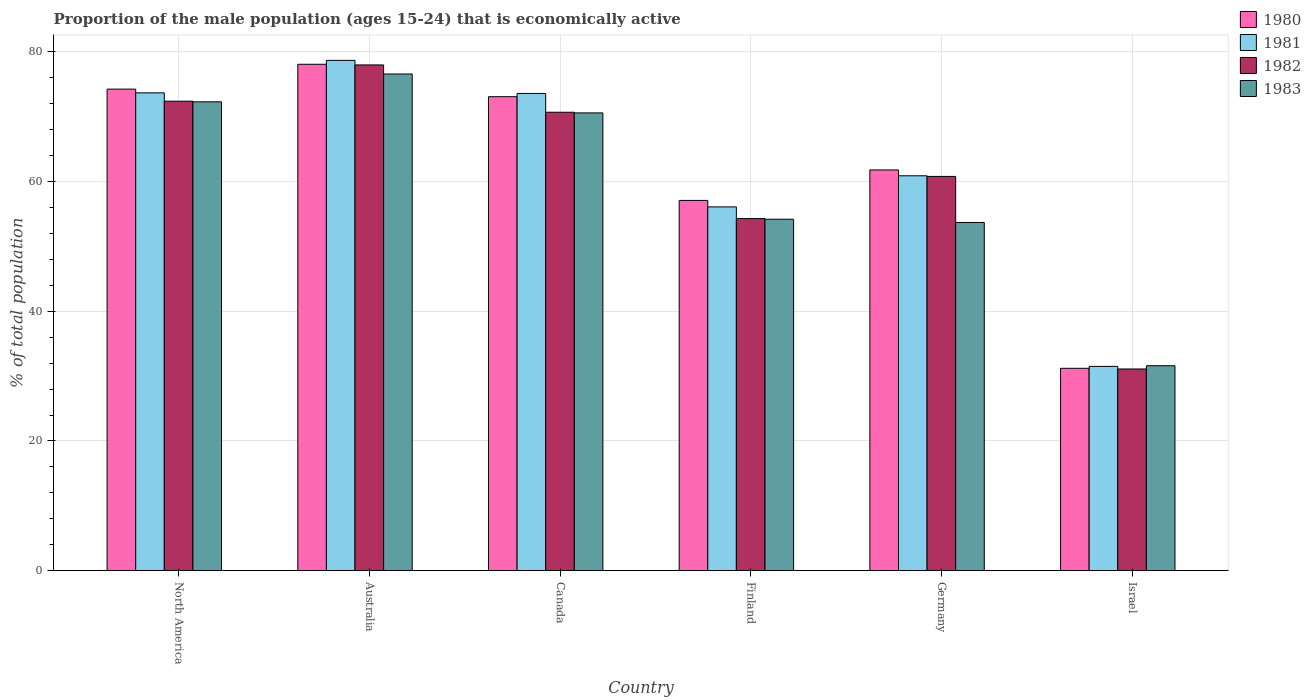How many different coloured bars are there?
Your answer should be very brief. 4. Are the number of bars per tick equal to the number of legend labels?
Your answer should be very brief. Yes. Are the number of bars on each tick of the X-axis equal?
Provide a succinct answer. Yes. What is the label of the 5th group of bars from the left?
Provide a succinct answer. Germany. In how many cases, is the number of bars for a given country not equal to the number of legend labels?
Give a very brief answer. 0. What is the proportion of the male population that is economically active in 1980 in Australia?
Offer a very short reply. 78.1. Across all countries, what is the maximum proportion of the male population that is economically active in 1980?
Offer a terse response. 78.1. Across all countries, what is the minimum proportion of the male population that is economically active in 1980?
Give a very brief answer. 31.2. What is the total proportion of the male population that is economically active in 1982 in the graph?
Provide a short and direct response. 367.31. What is the difference between the proportion of the male population that is economically active in 1981 in Canada and that in Germany?
Your response must be concise. 12.7. What is the difference between the proportion of the male population that is economically active in 1983 in Canada and the proportion of the male population that is economically active in 1980 in Germany?
Ensure brevity in your answer.  8.8. What is the average proportion of the male population that is economically active in 1981 per country?
Your answer should be very brief. 62.41. What is the difference between the proportion of the male population that is economically active of/in 1981 and proportion of the male population that is economically active of/in 1982 in Finland?
Your answer should be compact. 1.8. What is the ratio of the proportion of the male population that is economically active in 1980 in Canada to that in Israel?
Your answer should be compact. 2.34. Is the proportion of the male population that is economically active in 1980 in Canada less than that in Finland?
Keep it short and to the point. No. Is the difference between the proportion of the male population that is economically active in 1981 in Finland and Germany greater than the difference between the proportion of the male population that is economically active in 1982 in Finland and Germany?
Give a very brief answer. Yes. What is the difference between the highest and the second highest proportion of the male population that is economically active in 1982?
Your answer should be compact. 1.71. What is the difference between the highest and the lowest proportion of the male population that is economically active in 1982?
Offer a very short reply. 46.9. Is the sum of the proportion of the male population that is economically active in 1980 in Finland and Israel greater than the maximum proportion of the male population that is economically active in 1981 across all countries?
Give a very brief answer. Yes. Is it the case that in every country, the sum of the proportion of the male population that is economically active in 1983 and proportion of the male population that is economically active in 1982 is greater than the sum of proportion of the male population that is economically active in 1980 and proportion of the male population that is economically active in 1981?
Ensure brevity in your answer.  No. Is it the case that in every country, the sum of the proportion of the male population that is economically active in 1982 and proportion of the male population that is economically active in 1980 is greater than the proportion of the male population that is economically active in 1983?
Make the answer very short. Yes. Are all the bars in the graph horizontal?
Ensure brevity in your answer.  No. Where does the legend appear in the graph?
Give a very brief answer. Top right. How many legend labels are there?
Keep it short and to the point. 4. What is the title of the graph?
Provide a succinct answer. Proportion of the male population (ages 15-24) that is economically active. Does "1984" appear as one of the legend labels in the graph?
Provide a short and direct response. No. What is the label or title of the X-axis?
Provide a succinct answer. Country. What is the label or title of the Y-axis?
Offer a very short reply. % of total population. What is the % of total population in 1980 in North America?
Provide a succinct answer. 74.27. What is the % of total population of 1981 in North America?
Make the answer very short. 73.69. What is the % of total population in 1982 in North America?
Keep it short and to the point. 72.41. What is the % of total population of 1983 in North America?
Give a very brief answer. 72.31. What is the % of total population in 1980 in Australia?
Offer a terse response. 78.1. What is the % of total population in 1981 in Australia?
Keep it short and to the point. 78.7. What is the % of total population in 1982 in Australia?
Offer a terse response. 78. What is the % of total population in 1983 in Australia?
Ensure brevity in your answer.  76.6. What is the % of total population of 1980 in Canada?
Offer a very short reply. 73.1. What is the % of total population in 1981 in Canada?
Make the answer very short. 73.6. What is the % of total population in 1982 in Canada?
Provide a short and direct response. 70.7. What is the % of total population in 1983 in Canada?
Make the answer very short. 70.6. What is the % of total population in 1980 in Finland?
Provide a short and direct response. 57.1. What is the % of total population of 1981 in Finland?
Keep it short and to the point. 56.1. What is the % of total population in 1982 in Finland?
Your answer should be very brief. 54.3. What is the % of total population of 1983 in Finland?
Keep it short and to the point. 54.2. What is the % of total population of 1980 in Germany?
Provide a succinct answer. 61.8. What is the % of total population of 1981 in Germany?
Give a very brief answer. 60.9. What is the % of total population of 1982 in Germany?
Keep it short and to the point. 60.8. What is the % of total population in 1983 in Germany?
Your response must be concise. 53.7. What is the % of total population in 1980 in Israel?
Provide a short and direct response. 31.2. What is the % of total population of 1981 in Israel?
Make the answer very short. 31.5. What is the % of total population of 1982 in Israel?
Your answer should be compact. 31.1. What is the % of total population of 1983 in Israel?
Provide a succinct answer. 31.6. Across all countries, what is the maximum % of total population of 1980?
Offer a terse response. 78.1. Across all countries, what is the maximum % of total population of 1981?
Make the answer very short. 78.7. Across all countries, what is the maximum % of total population of 1982?
Your answer should be compact. 78. Across all countries, what is the maximum % of total population of 1983?
Make the answer very short. 76.6. Across all countries, what is the minimum % of total population of 1980?
Your answer should be compact. 31.2. Across all countries, what is the minimum % of total population of 1981?
Keep it short and to the point. 31.5. Across all countries, what is the minimum % of total population of 1982?
Provide a succinct answer. 31.1. Across all countries, what is the minimum % of total population of 1983?
Keep it short and to the point. 31.6. What is the total % of total population in 1980 in the graph?
Give a very brief answer. 375.57. What is the total % of total population in 1981 in the graph?
Provide a short and direct response. 374.49. What is the total % of total population of 1982 in the graph?
Offer a terse response. 367.31. What is the total % of total population of 1983 in the graph?
Give a very brief answer. 359.01. What is the difference between the % of total population in 1980 in North America and that in Australia?
Provide a short and direct response. -3.83. What is the difference between the % of total population of 1981 in North America and that in Australia?
Give a very brief answer. -5.01. What is the difference between the % of total population in 1982 in North America and that in Australia?
Your answer should be very brief. -5.59. What is the difference between the % of total population in 1983 in North America and that in Australia?
Offer a terse response. -4.29. What is the difference between the % of total population in 1980 in North America and that in Canada?
Make the answer very short. 1.17. What is the difference between the % of total population of 1981 in North America and that in Canada?
Provide a succinct answer. 0.09. What is the difference between the % of total population of 1982 in North America and that in Canada?
Give a very brief answer. 1.71. What is the difference between the % of total population of 1983 in North America and that in Canada?
Ensure brevity in your answer.  1.71. What is the difference between the % of total population in 1980 in North America and that in Finland?
Ensure brevity in your answer.  17.17. What is the difference between the % of total population in 1981 in North America and that in Finland?
Provide a succinct answer. 17.59. What is the difference between the % of total population of 1982 in North America and that in Finland?
Offer a terse response. 18.11. What is the difference between the % of total population of 1983 in North America and that in Finland?
Your response must be concise. 18.11. What is the difference between the % of total population in 1980 in North America and that in Germany?
Provide a short and direct response. 12.47. What is the difference between the % of total population in 1981 in North America and that in Germany?
Provide a short and direct response. 12.79. What is the difference between the % of total population in 1982 in North America and that in Germany?
Your response must be concise. 11.61. What is the difference between the % of total population of 1983 in North America and that in Germany?
Give a very brief answer. 18.61. What is the difference between the % of total population of 1980 in North America and that in Israel?
Give a very brief answer. 43.07. What is the difference between the % of total population of 1981 in North America and that in Israel?
Keep it short and to the point. 42.19. What is the difference between the % of total population in 1982 in North America and that in Israel?
Offer a terse response. 41.31. What is the difference between the % of total population of 1983 in North America and that in Israel?
Your response must be concise. 40.71. What is the difference between the % of total population of 1980 in Australia and that in Canada?
Your response must be concise. 5. What is the difference between the % of total population in 1981 in Australia and that in Canada?
Provide a short and direct response. 5.1. What is the difference between the % of total population of 1983 in Australia and that in Canada?
Give a very brief answer. 6. What is the difference between the % of total population in 1981 in Australia and that in Finland?
Give a very brief answer. 22.6. What is the difference between the % of total population of 1982 in Australia and that in Finland?
Give a very brief answer. 23.7. What is the difference between the % of total population of 1983 in Australia and that in Finland?
Keep it short and to the point. 22.4. What is the difference between the % of total population in 1980 in Australia and that in Germany?
Your answer should be very brief. 16.3. What is the difference between the % of total population of 1982 in Australia and that in Germany?
Your answer should be compact. 17.2. What is the difference between the % of total population in 1983 in Australia and that in Germany?
Give a very brief answer. 22.9. What is the difference between the % of total population in 1980 in Australia and that in Israel?
Your answer should be compact. 46.9. What is the difference between the % of total population of 1981 in Australia and that in Israel?
Give a very brief answer. 47.2. What is the difference between the % of total population in 1982 in Australia and that in Israel?
Offer a terse response. 46.9. What is the difference between the % of total population of 1982 in Canada and that in Finland?
Provide a short and direct response. 16.4. What is the difference between the % of total population of 1980 in Canada and that in Germany?
Offer a very short reply. 11.3. What is the difference between the % of total population of 1982 in Canada and that in Germany?
Make the answer very short. 9.9. What is the difference between the % of total population in 1983 in Canada and that in Germany?
Provide a succinct answer. 16.9. What is the difference between the % of total population in 1980 in Canada and that in Israel?
Offer a terse response. 41.9. What is the difference between the % of total population in 1981 in Canada and that in Israel?
Offer a very short reply. 42.1. What is the difference between the % of total population of 1982 in Canada and that in Israel?
Offer a very short reply. 39.6. What is the difference between the % of total population in 1980 in Finland and that in Germany?
Make the answer very short. -4.7. What is the difference between the % of total population of 1982 in Finland and that in Germany?
Give a very brief answer. -6.5. What is the difference between the % of total population in 1980 in Finland and that in Israel?
Make the answer very short. 25.9. What is the difference between the % of total population of 1981 in Finland and that in Israel?
Give a very brief answer. 24.6. What is the difference between the % of total population of 1982 in Finland and that in Israel?
Your answer should be compact. 23.2. What is the difference between the % of total population of 1983 in Finland and that in Israel?
Keep it short and to the point. 22.6. What is the difference between the % of total population in 1980 in Germany and that in Israel?
Your answer should be very brief. 30.6. What is the difference between the % of total population in 1981 in Germany and that in Israel?
Offer a terse response. 29.4. What is the difference between the % of total population in 1982 in Germany and that in Israel?
Your answer should be compact. 29.7. What is the difference between the % of total population in 1983 in Germany and that in Israel?
Ensure brevity in your answer.  22.1. What is the difference between the % of total population of 1980 in North America and the % of total population of 1981 in Australia?
Offer a terse response. -4.43. What is the difference between the % of total population in 1980 in North America and the % of total population in 1982 in Australia?
Provide a succinct answer. -3.73. What is the difference between the % of total population in 1980 in North America and the % of total population in 1983 in Australia?
Make the answer very short. -2.33. What is the difference between the % of total population in 1981 in North America and the % of total population in 1982 in Australia?
Keep it short and to the point. -4.31. What is the difference between the % of total population in 1981 in North America and the % of total population in 1983 in Australia?
Keep it short and to the point. -2.91. What is the difference between the % of total population of 1982 in North America and the % of total population of 1983 in Australia?
Your answer should be compact. -4.19. What is the difference between the % of total population in 1980 in North America and the % of total population in 1981 in Canada?
Offer a terse response. 0.67. What is the difference between the % of total population in 1980 in North America and the % of total population in 1982 in Canada?
Keep it short and to the point. 3.57. What is the difference between the % of total population of 1980 in North America and the % of total population of 1983 in Canada?
Keep it short and to the point. 3.67. What is the difference between the % of total population of 1981 in North America and the % of total population of 1982 in Canada?
Your answer should be very brief. 2.99. What is the difference between the % of total population of 1981 in North America and the % of total population of 1983 in Canada?
Keep it short and to the point. 3.09. What is the difference between the % of total population in 1982 in North America and the % of total population in 1983 in Canada?
Give a very brief answer. 1.81. What is the difference between the % of total population of 1980 in North America and the % of total population of 1981 in Finland?
Provide a succinct answer. 18.17. What is the difference between the % of total population of 1980 in North America and the % of total population of 1982 in Finland?
Your answer should be compact. 19.97. What is the difference between the % of total population of 1980 in North America and the % of total population of 1983 in Finland?
Your answer should be compact. 20.07. What is the difference between the % of total population of 1981 in North America and the % of total population of 1982 in Finland?
Give a very brief answer. 19.39. What is the difference between the % of total population of 1981 in North America and the % of total population of 1983 in Finland?
Offer a terse response. 19.49. What is the difference between the % of total population of 1982 in North America and the % of total population of 1983 in Finland?
Provide a short and direct response. 18.21. What is the difference between the % of total population in 1980 in North America and the % of total population in 1981 in Germany?
Keep it short and to the point. 13.37. What is the difference between the % of total population of 1980 in North America and the % of total population of 1982 in Germany?
Offer a very short reply. 13.47. What is the difference between the % of total population in 1980 in North America and the % of total population in 1983 in Germany?
Your response must be concise. 20.57. What is the difference between the % of total population of 1981 in North America and the % of total population of 1982 in Germany?
Provide a succinct answer. 12.89. What is the difference between the % of total population of 1981 in North America and the % of total population of 1983 in Germany?
Provide a succinct answer. 19.99. What is the difference between the % of total population of 1982 in North America and the % of total population of 1983 in Germany?
Offer a very short reply. 18.71. What is the difference between the % of total population of 1980 in North America and the % of total population of 1981 in Israel?
Keep it short and to the point. 42.77. What is the difference between the % of total population of 1980 in North America and the % of total population of 1982 in Israel?
Your response must be concise. 43.17. What is the difference between the % of total population in 1980 in North America and the % of total population in 1983 in Israel?
Provide a succinct answer. 42.67. What is the difference between the % of total population in 1981 in North America and the % of total population in 1982 in Israel?
Ensure brevity in your answer.  42.59. What is the difference between the % of total population in 1981 in North America and the % of total population in 1983 in Israel?
Keep it short and to the point. 42.09. What is the difference between the % of total population of 1982 in North America and the % of total population of 1983 in Israel?
Give a very brief answer. 40.81. What is the difference between the % of total population in 1980 in Australia and the % of total population in 1981 in Canada?
Make the answer very short. 4.5. What is the difference between the % of total population of 1981 in Australia and the % of total population of 1982 in Canada?
Keep it short and to the point. 8. What is the difference between the % of total population of 1981 in Australia and the % of total population of 1983 in Canada?
Provide a short and direct response. 8.1. What is the difference between the % of total population in 1982 in Australia and the % of total population in 1983 in Canada?
Ensure brevity in your answer.  7.4. What is the difference between the % of total population of 1980 in Australia and the % of total population of 1981 in Finland?
Provide a succinct answer. 22. What is the difference between the % of total population of 1980 in Australia and the % of total population of 1982 in Finland?
Your answer should be very brief. 23.8. What is the difference between the % of total population of 1980 in Australia and the % of total population of 1983 in Finland?
Your answer should be compact. 23.9. What is the difference between the % of total population in 1981 in Australia and the % of total population in 1982 in Finland?
Make the answer very short. 24.4. What is the difference between the % of total population in 1982 in Australia and the % of total population in 1983 in Finland?
Provide a short and direct response. 23.8. What is the difference between the % of total population in 1980 in Australia and the % of total population in 1983 in Germany?
Your response must be concise. 24.4. What is the difference between the % of total population in 1981 in Australia and the % of total population in 1982 in Germany?
Provide a succinct answer. 17.9. What is the difference between the % of total population in 1981 in Australia and the % of total population in 1983 in Germany?
Your answer should be compact. 25. What is the difference between the % of total population in 1982 in Australia and the % of total population in 1983 in Germany?
Give a very brief answer. 24.3. What is the difference between the % of total population in 1980 in Australia and the % of total population in 1981 in Israel?
Give a very brief answer. 46.6. What is the difference between the % of total population of 1980 in Australia and the % of total population of 1983 in Israel?
Keep it short and to the point. 46.5. What is the difference between the % of total population in 1981 in Australia and the % of total population in 1982 in Israel?
Provide a short and direct response. 47.6. What is the difference between the % of total population in 1981 in Australia and the % of total population in 1983 in Israel?
Offer a very short reply. 47.1. What is the difference between the % of total population in 1982 in Australia and the % of total population in 1983 in Israel?
Provide a short and direct response. 46.4. What is the difference between the % of total population of 1980 in Canada and the % of total population of 1983 in Finland?
Ensure brevity in your answer.  18.9. What is the difference between the % of total population of 1981 in Canada and the % of total population of 1982 in Finland?
Provide a succinct answer. 19.3. What is the difference between the % of total population in 1981 in Canada and the % of total population in 1983 in Germany?
Your response must be concise. 19.9. What is the difference between the % of total population of 1982 in Canada and the % of total population of 1983 in Germany?
Your answer should be compact. 17. What is the difference between the % of total population in 1980 in Canada and the % of total population in 1981 in Israel?
Offer a terse response. 41.6. What is the difference between the % of total population in 1980 in Canada and the % of total population in 1982 in Israel?
Provide a short and direct response. 42. What is the difference between the % of total population of 1980 in Canada and the % of total population of 1983 in Israel?
Provide a succinct answer. 41.5. What is the difference between the % of total population of 1981 in Canada and the % of total population of 1982 in Israel?
Provide a succinct answer. 42.5. What is the difference between the % of total population of 1982 in Canada and the % of total population of 1983 in Israel?
Offer a terse response. 39.1. What is the difference between the % of total population in 1981 in Finland and the % of total population in 1983 in Germany?
Make the answer very short. 2.4. What is the difference between the % of total population in 1980 in Finland and the % of total population in 1981 in Israel?
Your response must be concise. 25.6. What is the difference between the % of total population in 1980 in Finland and the % of total population in 1982 in Israel?
Provide a succinct answer. 26. What is the difference between the % of total population in 1980 in Finland and the % of total population in 1983 in Israel?
Your answer should be compact. 25.5. What is the difference between the % of total population in 1981 in Finland and the % of total population in 1982 in Israel?
Ensure brevity in your answer.  25. What is the difference between the % of total population of 1981 in Finland and the % of total population of 1983 in Israel?
Give a very brief answer. 24.5. What is the difference between the % of total population in 1982 in Finland and the % of total population in 1983 in Israel?
Your answer should be very brief. 22.7. What is the difference between the % of total population of 1980 in Germany and the % of total population of 1981 in Israel?
Provide a succinct answer. 30.3. What is the difference between the % of total population of 1980 in Germany and the % of total population of 1982 in Israel?
Your answer should be very brief. 30.7. What is the difference between the % of total population of 1980 in Germany and the % of total population of 1983 in Israel?
Offer a very short reply. 30.2. What is the difference between the % of total population of 1981 in Germany and the % of total population of 1982 in Israel?
Provide a short and direct response. 29.8. What is the difference between the % of total population of 1981 in Germany and the % of total population of 1983 in Israel?
Offer a very short reply. 29.3. What is the difference between the % of total population of 1982 in Germany and the % of total population of 1983 in Israel?
Offer a very short reply. 29.2. What is the average % of total population in 1980 per country?
Your response must be concise. 62.59. What is the average % of total population of 1981 per country?
Ensure brevity in your answer.  62.41. What is the average % of total population in 1982 per country?
Provide a short and direct response. 61.22. What is the average % of total population in 1983 per country?
Offer a very short reply. 59.83. What is the difference between the % of total population of 1980 and % of total population of 1981 in North America?
Your response must be concise. 0.58. What is the difference between the % of total population of 1980 and % of total population of 1982 in North America?
Make the answer very short. 1.86. What is the difference between the % of total population in 1980 and % of total population in 1983 in North America?
Your answer should be compact. 1.96. What is the difference between the % of total population in 1981 and % of total population in 1982 in North America?
Offer a very short reply. 1.28. What is the difference between the % of total population in 1981 and % of total population in 1983 in North America?
Your response must be concise. 1.38. What is the difference between the % of total population of 1982 and % of total population of 1983 in North America?
Offer a very short reply. 0.1. What is the difference between the % of total population in 1981 and % of total population in 1982 in Australia?
Provide a succinct answer. 0.7. What is the difference between the % of total population of 1982 and % of total population of 1983 in Australia?
Provide a succinct answer. 1.4. What is the difference between the % of total population of 1981 and % of total population of 1983 in Canada?
Provide a short and direct response. 3. What is the difference between the % of total population in 1980 and % of total population in 1981 in Finland?
Your response must be concise. 1. What is the difference between the % of total population in 1980 and % of total population in 1982 in Finland?
Offer a very short reply. 2.8. What is the difference between the % of total population of 1981 and % of total population of 1983 in Finland?
Ensure brevity in your answer.  1.9. What is the difference between the % of total population in 1980 and % of total population in 1982 in Germany?
Give a very brief answer. 1. What is the difference between the % of total population of 1981 and % of total population of 1983 in Germany?
Ensure brevity in your answer.  7.2. What is the difference between the % of total population of 1980 and % of total population of 1982 in Israel?
Offer a terse response. 0.1. What is the difference between the % of total population of 1981 and % of total population of 1982 in Israel?
Your response must be concise. 0.4. What is the difference between the % of total population of 1982 and % of total population of 1983 in Israel?
Keep it short and to the point. -0.5. What is the ratio of the % of total population in 1980 in North America to that in Australia?
Keep it short and to the point. 0.95. What is the ratio of the % of total population of 1981 in North America to that in Australia?
Your answer should be compact. 0.94. What is the ratio of the % of total population in 1982 in North America to that in Australia?
Ensure brevity in your answer.  0.93. What is the ratio of the % of total population of 1983 in North America to that in Australia?
Make the answer very short. 0.94. What is the ratio of the % of total population of 1980 in North America to that in Canada?
Give a very brief answer. 1.02. What is the ratio of the % of total population of 1981 in North America to that in Canada?
Offer a terse response. 1. What is the ratio of the % of total population in 1982 in North America to that in Canada?
Your answer should be very brief. 1.02. What is the ratio of the % of total population in 1983 in North America to that in Canada?
Your answer should be compact. 1.02. What is the ratio of the % of total population of 1980 in North America to that in Finland?
Offer a terse response. 1.3. What is the ratio of the % of total population in 1981 in North America to that in Finland?
Keep it short and to the point. 1.31. What is the ratio of the % of total population in 1982 in North America to that in Finland?
Your answer should be compact. 1.33. What is the ratio of the % of total population of 1983 in North America to that in Finland?
Your answer should be very brief. 1.33. What is the ratio of the % of total population of 1980 in North America to that in Germany?
Ensure brevity in your answer.  1.2. What is the ratio of the % of total population of 1981 in North America to that in Germany?
Your answer should be compact. 1.21. What is the ratio of the % of total population in 1982 in North America to that in Germany?
Ensure brevity in your answer.  1.19. What is the ratio of the % of total population in 1983 in North America to that in Germany?
Your response must be concise. 1.35. What is the ratio of the % of total population of 1980 in North America to that in Israel?
Give a very brief answer. 2.38. What is the ratio of the % of total population of 1981 in North America to that in Israel?
Provide a short and direct response. 2.34. What is the ratio of the % of total population of 1982 in North America to that in Israel?
Provide a succinct answer. 2.33. What is the ratio of the % of total population of 1983 in North America to that in Israel?
Provide a short and direct response. 2.29. What is the ratio of the % of total population of 1980 in Australia to that in Canada?
Offer a terse response. 1.07. What is the ratio of the % of total population in 1981 in Australia to that in Canada?
Offer a very short reply. 1.07. What is the ratio of the % of total population in 1982 in Australia to that in Canada?
Provide a short and direct response. 1.1. What is the ratio of the % of total population of 1983 in Australia to that in Canada?
Your answer should be compact. 1.08. What is the ratio of the % of total population in 1980 in Australia to that in Finland?
Offer a terse response. 1.37. What is the ratio of the % of total population in 1981 in Australia to that in Finland?
Make the answer very short. 1.4. What is the ratio of the % of total population of 1982 in Australia to that in Finland?
Provide a succinct answer. 1.44. What is the ratio of the % of total population in 1983 in Australia to that in Finland?
Your answer should be compact. 1.41. What is the ratio of the % of total population of 1980 in Australia to that in Germany?
Give a very brief answer. 1.26. What is the ratio of the % of total population of 1981 in Australia to that in Germany?
Ensure brevity in your answer.  1.29. What is the ratio of the % of total population in 1982 in Australia to that in Germany?
Ensure brevity in your answer.  1.28. What is the ratio of the % of total population of 1983 in Australia to that in Germany?
Provide a short and direct response. 1.43. What is the ratio of the % of total population in 1980 in Australia to that in Israel?
Offer a terse response. 2.5. What is the ratio of the % of total population of 1981 in Australia to that in Israel?
Provide a short and direct response. 2.5. What is the ratio of the % of total population of 1982 in Australia to that in Israel?
Provide a short and direct response. 2.51. What is the ratio of the % of total population in 1983 in Australia to that in Israel?
Provide a succinct answer. 2.42. What is the ratio of the % of total population of 1980 in Canada to that in Finland?
Ensure brevity in your answer.  1.28. What is the ratio of the % of total population in 1981 in Canada to that in Finland?
Provide a short and direct response. 1.31. What is the ratio of the % of total population of 1982 in Canada to that in Finland?
Your answer should be very brief. 1.3. What is the ratio of the % of total population in 1983 in Canada to that in Finland?
Your answer should be compact. 1.3. What is the ratio of the % of total population of 1980 in Canada to that in Germany?
Keep it short and to the point. 1.18. What is the ratio of the % of total population in 1981 in Canada to that in Germany?
Keep it short and to the point. 1.21. What is the ratio of the % of total population in 1982 in Canada to that in Germany?
Offer a terse response. 1.16. What is the ratio of the % of total population of 1983 in Canada to that in Germany?
Provide a succinct answer. 1.31. What is the ratio of the % of total population of 1980 in Canada to that in Israel?
Make the answer very short. 2.34. What is the ratio of the % of total population of 1981 in Canada to that in Israel?
Give a very brief answer. 2.34. What is the ratio of the % of total population of 1982 in Canada to that in Israel?
Offer a terse response. 2.27. What is the ratio of the % of total population in 1983 in Canada to that in Israel?
Your answer should be compact. 2.23. What is the ratio of the % of total population of 1980 in Finland to that in Germany?
Offer a terse response. 0.92. What is the ratio of the % of total population of 1981 in Finland to that in Germany?
Offer a terse response. 0.92. What is the ratio of the % of total population of 1982 in Finland to that in Germany?
Your answer should be compact. 0.89. What is the ratio of the % of total population of 1983 in Finland to that in Germany?
Make the answer very short. 1.01. What is the ratio of the % of total population of 1980 in Finland to that in Israel?
Give a very brief answer. 1.83. What is the ratio of the % of total population of 1981 in Finland to that in Israel?
Your answer should be very brief. 1.78. What is the ratio of the % of total population of 1982 in Finland to that in Israel?
Provide a succinct answer. 1.75. What is the ratio of the % of total population of 1983 in Finland to that in Israel?
Your response must be concise. 1.72. What is the ratio of the % of total population in 1980 in Germany to that in Israel?
Provide a succinct answer. 1.98. What is the ratio of the % of total population in 1981 in Germany to that in Israel?
Ensure brevity in your answer.  1.93. What is the ratio of the % of total population in 1982 in Germany to that in Israel?
Your response must be concise. 1.96. What is the ratio of the % of total population in 1983 in Germany to that in Israel?
Give a very brief answer. 1.7. What is the difference between the highest and the second highest % of total population of 1980?
Keep it short and to the point. 3.83. What is the difference between the highest and the second highest % of total population in 1981?
Offer a terse response. 5.01. What is the difference between the highest and the second highest % of total population of 1982?
Provide a short and direct response. 5.59. What is the difference between the highest and the second highest % of total population in 1983?
Provide a short and direct response. 4.29. What is the difference between the highest and the lowest % of total population in 1980?
Ensure brevity in your answer.  46.9. What is the difference between the highest and the lowest % of total population of 1981?
Provide a short and direct response. 47.2. What is the difference between the highest and the lowest % of total population in 1982?
Your response must be concise. 46.9. What is the difference between the highest and the lowest % of total population in 1983?
Offer a very short reply. 45. 